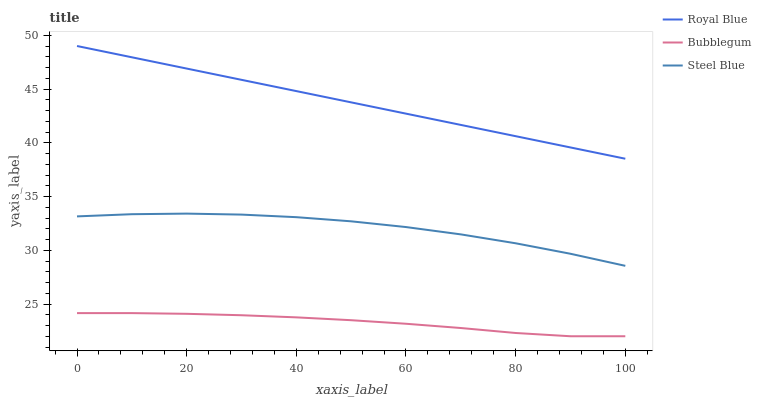Does Bubblegum have the minimum area under the curve?
Answer yes or no. Yes. Does Royal Blue have the maximum area under the curve?
Answer yes or no. Yes. Does Steel Blue have the minimum area under the curve?
Answer yes or no. No. Does Steel Blue have the maximum area under the curve?
Answer yes or no. No. Is Royal Blue the smoothest?
Answer yes or no. Yes. Is Steel Blue the roughest?
Answer yes or no. Yes. Is Bubblegum the smoothest?
Answer yes or no. No. Is Bubblegum the roughest?
Answer yes or no. No. Does Bubblegum have the lowest value?
Answer yes or no. Yes. Does Steel Blue have the lowest value?
Answer yes or no. No. Does Royal Blue have the highest value?
Answer yes or no. Yes. Does Steel Blue have the highest value?
Answer yes or no. No. Is Bubblegum less than Steel Blue?
Answer yes or no. Yes. Is Royal Blue greater than Bubblegum?
Answer yes or no. Yes. Does Bubblegum intersect Steel Blue?
Answer yes or no. No. 